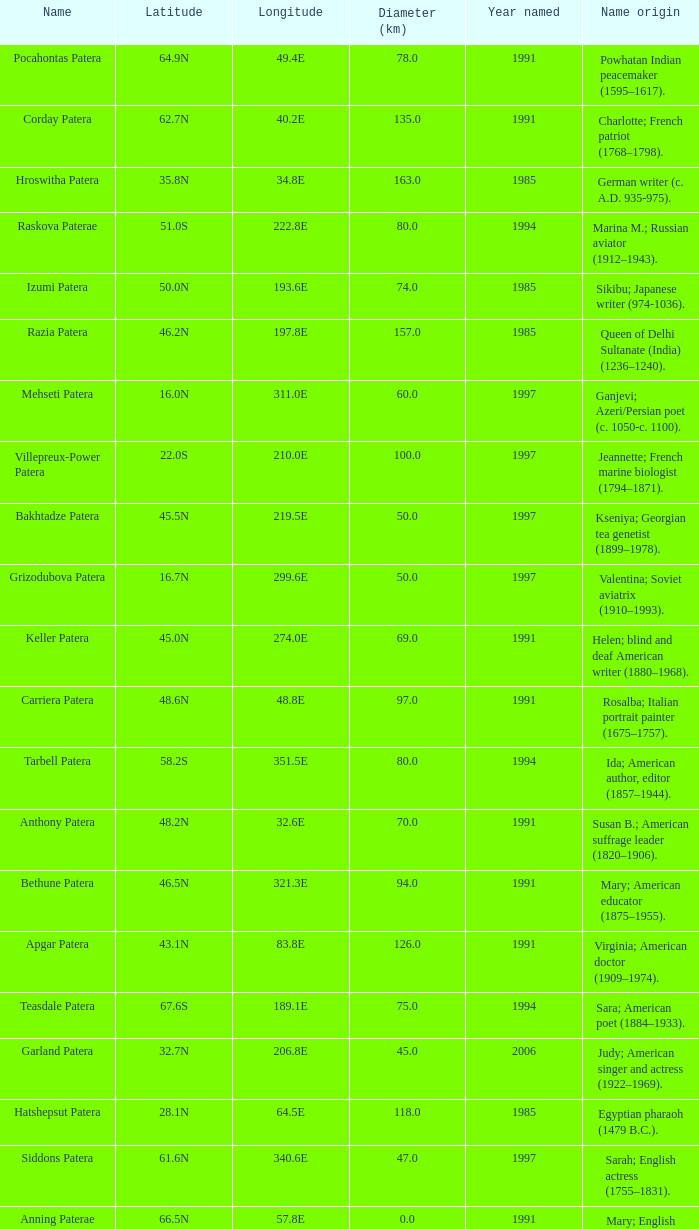What is the origin of the name of Keller Patera?  Helen; blind and deaf American writer (1880–1968). 